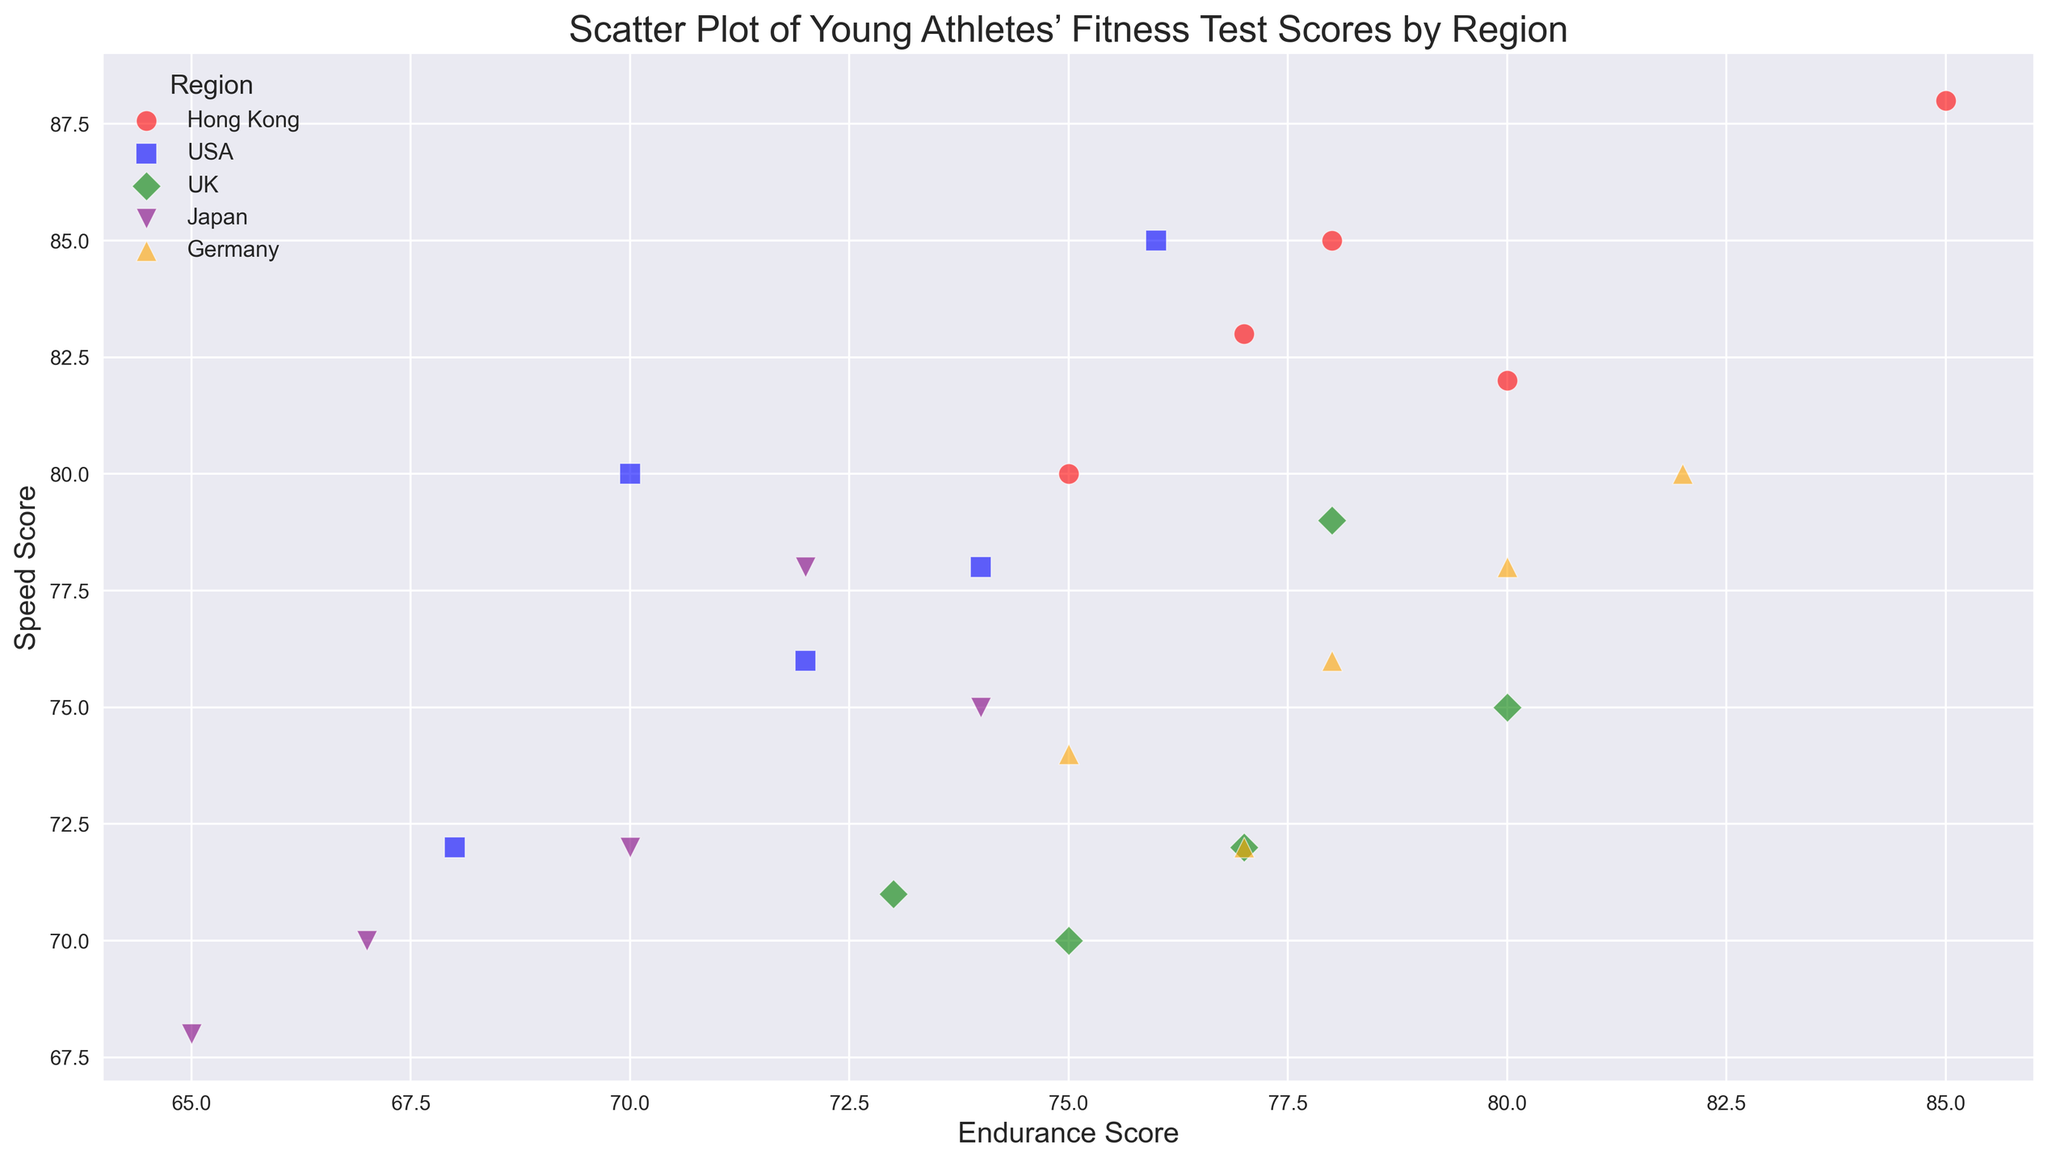Hong Kong的體能測試成績分布是怎麼樣的？ 從圖中可以看到，Hong Kong區域的測試數據標示為紅色的圓圈，主要集中在Endurance Score為75到85之間，Speed Score為80到88之間。
Answer: Endurance在75-85之間，Speed在80-88之間 哪個地區的Speed Score的分布範圍最大？ 比較所有地區的Speed Score的最低值和最高值，可以看到USA區域的Speed Score範圍從72到85，是最大的。
Answer: USA 香港和日本運動員的Speed Score相比，哪個地區分數較高？ 香港運動員的Speed Score範圍是80到88，而日本運動員的Speed Score範圍是68到78。比較這兩個範圍，香港運動員的分數顯著較高。
Answer: 香港 UK和Germany的Endurance Score的中心趨勢在哪裡？ UK區域的Endurance Score範圍是73到80，德國的範圍是75到82。UK的中間值大約在77，Germany的中間值大約在78。
Answer: UK大約在77, Germany大約在78 不同地區中哪個地區的運動員的體能測試整體表現最好？ 綜合考慮Endurance Score和Speed Score的範圍，德國運動員的表現最好，因為他們的Endurance Score和Speed Score均在較高的範圍內：Endurance Score在75-82之間，Speed Score在72-80之間。
Answer: 德國 日本運動員的Endurance Score集中在哪個區間？ 日本地區的Endurance Score集中在65到74之間。
Answer: 65-74 哪個地區的Endurance Score和Speed Score的相關性最強？ 觀察散點圖的分佈密度和斜率，德國和香港的Endurance Score和Speed Score呈現較強相關性，且變動較一致。
Answer: 德國和香港 在所有地區中，哪個地區的運動員的Flexibility Score分布較均勻？ 可以看到Flexibility Score數據點的分布，UK的分布較均勻，數值分布在63到70之間。
Answer: UK 